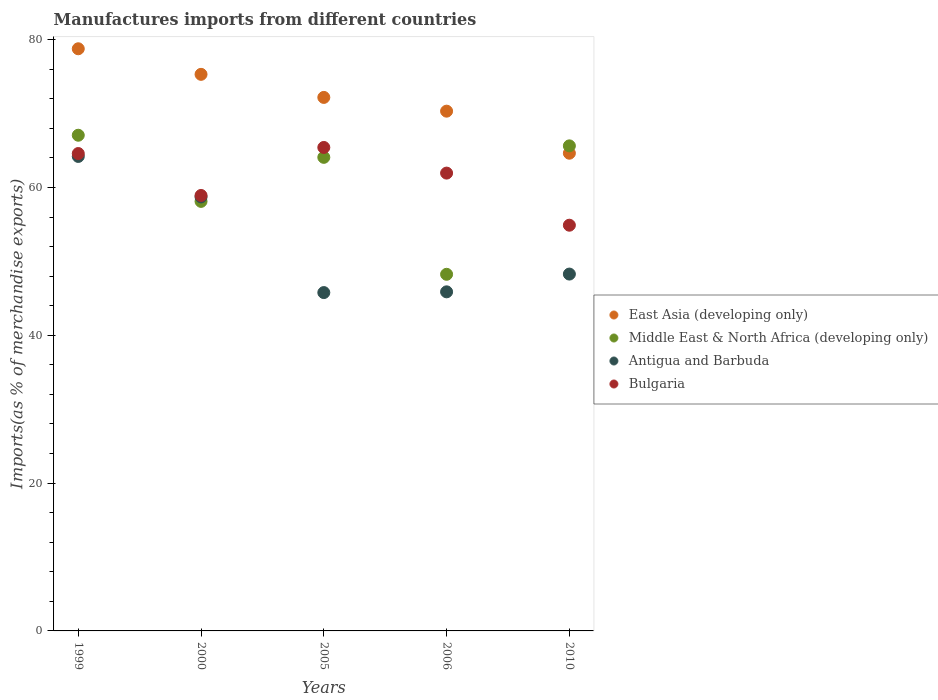How many different coloured dotlines are there?
Make the answer very short. 4. Is the number of dotlines equal to the number of legend labels?
Give a very brief answer. Yes. What is the percentage of imports to different countries in East Asia (developing only) in 2010?
Your answer should be compact. 64.64. Across all years, what is the maximum percentage of imports to different countries in East Asia (developing only)?
Keep it short and to the point. 78.77. Across all years, what is the minimum percentage of imports to different countries in Middle East & North Africa (developing only)?
Your answer should be very brief. 48.25. What is the total percentage of imports to different countries in East Asia (developing only) in the graph?
Your answer should be very brief. 361.24. What is the difference between the percentage of imports to different countries in Middle East & North Africa (developing only) in 1999 and that in 2006?
Provide a succinct answer. 18.82. What is the difference between the percentage of imports to different countries in Middle East & North Africa (developing only) in 2006 and the percentage of imports to different countries in East Asia (developing only) in 1999?
Keep it short and to the point. -30.52. What is the average percentage of imports to different countries in Bulgaria per year?
Give a very brief answer. 61.16. In the year 2000, what is the difference between the percentage of imports to different countries in Bulgaria and percentage of imports to different countries in East Asia (developing only)?
Offer a very short reply. -16.39. What is the ratio of the percentage of imports to different countries in Middle East & North Africa (developing only) in 1999 to that in 2010?
Keep it short and to the point. 1.02. What is the difference between the highest and the second highest percentage of imports to different countries in Middle East & North Africa (developing only)?
Your response must be concise. 1.44. What is the difference between the highest and the lowest percentage of imports to different countries in Antigua and Barbuda?
Give a very brief answer. 18.42. In how many years, is the percentage of imports to different countries in East Asia (developing only) greater than the average percentage of imports to different countries in East Asia (developing only) taken over all years?
Give a very brief answer. 2. Is it the case that in every year, the sum of the percentage of imports to different countries in Antigua and Barbuda and percentage of imports to different countries in Middle East & North Africa (developing only)  is greater than the sum of percentage of imports to different countries in Bulgaria and percentage of imports to different countries in East Asia (developing only)?
Make the answer very short. No. How many dotlines are there?
Give a very brief answer. 4. How many years are there in the graph?
Your answer should be very brief. 5. What is the difference between two consecutive major ticks on the Y-axis?
Provide a succinct answer. 20. Are the values on the major ticks of Y-axis written in scientific E-notation?
Make the answer very short. No. Does the graph contain any zero values?
Provide a succinct answer. No. Does the graph contain grids?
Offer a very short reply. No. How many legend labels are there?
Offer a terse response. 4. What is the title of the graph?
Make the answer very short. Manufactures imports from different countries. What is the label or title of the X-axis?
Your answer should be very brief. Years. What is the label or title of the Y-axis?
Your answer should be compact. Imports(as % of merchandise exports). What is the Imports(as % of merchandise exports) of East Asia (developing only) in 1999?
Keep it short and to the point. 78.77. What is the Imports(as % of merchandise exports) of Middle East & North Africa (developing only) in 1999?
Your answer should be very brief. 67.07. What is the Imports(as % of merchandise exports) in Antigua and Barbuda in 1999?
Offer a terse response. 64.2. What is the Imports(as % of merchandise exports) of Bulgaria in 1999?
Your response must be concise. 64.6. What is the Imports(as % of merchandise exports) of East Asia (developing only) in 2000?
Keep it short and to the point. 75.31. What is the Imports(as % of merchandise exports) of Middle East & North Africa (developing only) in 2000?
Your answer should be very brief. 58.12. What is the Imports(as % of merchandise exports) of Antigua and Barbuda in 2000?
Your response must be concise. 58.72. What is the Imports(as % of merchandise exports) in Bulgaria in 2000?
Offer a terse response. 58.92. What is the Imports(as % of merchandise exports) of East Asia (developing only) in 2005?
Your response must be concise. 72.19. What is the Imports(as % of merchandise exports) in Middle East & North Africa (developing only) in 2005?
Make the answer very short. 64.08. What is the Imports(as % of merchandise exports) of Antigua and Barbuda in 2005?
Your answer should be compact. 45.78. What is the Imports(as % of merchandise exports) in Bulgaria in 2005?
Offer a very short reply. 65.42. What is the Imports(as % of merchandise exports) in East Asia (developing only) in 2006?
Offer a terse response. 70.33. What is the Imports(as % of merchandise exports) in Middle East & North Africa (developing only) in 2006?
Your response must be concise. 48.25. What is the Imports(as % of merchandise exports) in Antigua and Barbuda in 2006?
Provide a short and direct response. 45.88. What is the Imports(as % of merchandise exports) in Bulgaria in 2006?
Offer a terse response. 61.95. What is the Imports(as % of merchandise exports) in East Asia (developing only) in 2010?
Give a very brief answer. 64.64. What is the Imports(as % of merchandise exports) in Middle East & North Africa (developing only) in 2010?
Keep it short and to the point. 65.63. What is the Imports(as % of merchandise exports) in Antigua and Barbuda in 2010?
Your response must be concise. 48.29. What is the Imports(as % of merchandise exports) in Bulgaria in 2010?
Your answer should be very brief. 54.9. Across all years, what is the maximum Imports(as % of merchandise exports) of East Asia (developing only)?
Offer a very short reply. 78.77. Across all years, what is the maximum Imports(as % of merchandise exports) in Middle East & North Africa (developing only)?
Provide a short and direct response. 67.07. Across all years, what is the maximum Imports(as % of merchandise exports) of Antigua and Barbuda?
Offer a terse response. 64.2. Across all years, what is the maximum Imports(as % of merchandise exports) in Bulgaria?
Your response must be concise. 65.42. Across all years, what is the minimum Imports(as % of merchandise exports) in East Asia (developing only)?
Your answer should be very brief. 64.64. Across all years, what is the minimum Imports(as % of merchandise exports) in Middle East & North Africa (developing only)?
Give a very brief answer. 48.25. Across all years, what is the minimum Imports(as % of merchandise exports) of Antigua and Barbuda?
Keep it short and to the point. 45.78. Across all years, what is the minimum Imports(as % of merchandise exports) in Bulgaria?
Your answer should be very brief. 54.9. What is the total Imports(as % of merchandise exports) of East Asia (developing only) in the graph?
Your response must be concise. 361.24. What is the total Imports(as % of merchandise exports) in Middle East & North Africa (developing only) in the graph?
Offer a very short reply. 303.16. What is the total Imports(as % of merchandise exports) in Antigua and Barbuda in the graph?
Your answer should be compact. 262.88. What is the total Imports(as % of merchandise exports) in Bulgaria in the graph?
Your response must be concise. 305.78. What is the difference between the Imports(as % of merchandise exports) in East Asia (developing only) in 1999 and that in 2000?
Offer a very short reply. 3.46. What is the difference between the Imports(as % of merchandise exports) of Middle East & North Africa (developing only) in 1999 and that in 2000?
Your answer should be very brief. 8.95. What is the difference between the Imports(as % of merchandise exports) in Antigua and Barbuda in 1999 and that in 2000?
Your answer should be very brief. 5.48. What is the difference between the Imports(as % of merchandise exports) in Bulgaria in 1999 and that in 2000?
Provide a short and direct response. 5.67. What is the difference between the Imports(as % of merchandise exports) of East Asia (developing only) in 1999 and that in 2005?
Make the answer very short. 6.58. What is the difference between the Imports(as % of merchandise exports) of Middle East & North Africa (developing only) in 1999 and that in 2005?
Ensure brevity in your answer.  2.99. What is the difference between the Imports(as % of merchandise exports) of Antigua and Barbuda in 1999 and that in 2005?
Your answer should be very brief. 18.42. What is the difference between the Imports(as % of merchandise exports) of Bulgaria in 1999 and that in 2005?
Keep it short and to the point. -0.82. What is the difference between the Imports(as % of merchandise exports) in East Asia (developing only) in 1999 and that in 2006?
Provide a short and direct response. 8.44. What is the difference between the Imports(as % of merchandise exports) in Middle East & North Africa (developing only) in 1999 and that in 2006?
Ensure brevity in your answer.  18.82. What is the difference between the Imports(as % of merchandise exports) of Antigua and Barbuda in 1999 and that in 2006?
Ensure brevity in your answer.  18.32. What is the difference between the Imports(as % of merchandise exports) in Bulgaria in 1999 and that in 2006?
Offer a very short reply. 2.65. What is the difference between the Imports(as % of merchandise exports) of East Asia (developing only) in 1999 and that in 2010?
Your response must be concise. 14.13. What is the difference between the Imports(as % of merchandise exports) of Middle East & North Africa (developing only) in 1999 and that in 2010?
Provide a short and direct response. 1.44. What is the difference between the Imports(as % of merchandise exports) in Antigua and Barbuda in 1999 and that in 2010?
Offer a very short reply. 15.92. What is the difference between the Imports(as % of merchandise exports) in Bulgaria in 1999 and that in 2010?
Provide a short and direct response. 9.7. What is the difference between the Imports(as % of merchandise exports) in East Asia (developing only) in 2000 and that in 2005?
Your answer should be very brief. 3.12. What is the difference between the Imports(as % of merchandise exports) of Middle East & North Africa (developing only) in 2000 and that in 2005?
Ensure brevity in your answer.  -5.96. What is the difference between the Imports(as % of merchandise exports) of Antigua and Barbuda in 2000 and that in 2005?
Your response must be concise. 12.94. What is the difference between the Imports(as % of merchandise exports) in Bulgaria in 2000 and that in 2005?
Make the answer very short. -6.49. What is the difference between the Imports(as % of merchandise exports) in East Asia (developing only) in 2000 and that in 2006?
Give a very brief answer. 4.98. What is the difference between the Imports(as % of merchandise exports) in Middle East & North Africa (developing only) in 2000 and that in 2006?
Offer a terse response. 9.87. What is the difference between the Imports(as % of merchandise exports) of Antigua and Barbuda in 2000 and that in 2006?
Your response must be concise. 12.84. What is the difference between the Imports(as % of merchandise exports) of Bulgaria in 2000 and that in 2006?
Your answer should be compact. -3.03. What is the difference between the Imports(as % of merchandise exports) of East Asia (developing only) in 2000 and that in 2010?
Offer a terse response. 10.67. What is the difference between the Imports(as % of merchandise exports) of Middle East & North Africa (developing only) in 2000 and that in 2010?
Your response must be concise. -7.51. What is the difference between the Imports(as % of merchandise exports) of Antigua and Barbuda in 2000 and that in 2010?
Offer a terse response. 10.44. What is the difference between the Imports(as % of merchandise exports) in Bulgaria in 2000 and that in 2010?
Ensure brevity in your answer.  4.02. What is the difference between the Imports(as % of merchandise exports) of East Asia (developing only) in 2005 and that in 2006?
Offer a very short reply. 1.86. What is the difference between the Imports(as % of merchandise exports) in Middle East & North Africa (developing only) in 2005 and that in 2006?
Offer a terse response. 15.83. What is the difference between the Imports(as % of merchandise exports) of Antigua and Barbuda in 2005 and that in 2006?
Offer a very short reply. -0.1. What is the difference between the Imports(as % of merchandise exports) in Bulgaria in 2005 and that in 2006?
Give a very brief answer. 3.47. What is the difference between the Imports(as % of merchandise exports) of East Asia (developing only) in 2005 and that in 2010?
Offer a very short reply. 7.55. What is the difference between the Imports(as % of merchandise exports) of Middle East & North Africa (developing only) in 2005 and that in 2010?
Ensure brevity in your answer.  -1.55. What is the difference between the Imports(as % of merchandise exports) in Antigua and Barbuda in 2005 and that in 2010?
Your answer should be very brief. -2.5. What is the difference between the Imports(as % of merchandise exports) in Bulgaria in 2005 and that in 2010?
Your answer should be very brief. 10.52. What is the difference between the Imports(as % of merchandise exports) in East Asia (developing only) in 2006 and that in 2010?
Offer a very short reply. 5.69. What is the difference between the Imports(as % of merchandise exports) in Middle East & North Africa (developing only) in 2006 and that in 2010?
Ensure brevity in your answer.  -17.38. What is the difference between the Imports(as % of merchandise exports) of Antigua and Barbuda in 2006 and that in 2010?
Provide a short and direct response. -2.4. What is the difference between the Imports(as % of merchandise exports) of Bulgaria in 2006 and that in 2010?
Give a very brief answer. 7.05. What is the difference between the Imports(as % of merchandise exports) in East Asia (developing only) in 1999 and the Imports(as % of merchandise exports) in Middle East & North Africa (developing only) in 2000?
Your answer should be compact. 20.65. What is the difference between the Imports(as % of merchandise exports) in East Asia (developing only) in 1999 and the Imports(as % of merchandise exports) in Antigua and Barbuda in 2000?
Make the answer very short. 20.05. What is the difference between the Imports(as % of merchandise exports) of East Asia (developing only) in 1999 and the Imports(as % of merchandise exports) of Bulgaria in 2000?
Offer a very short reply. 19.85. What is the difference between the Imports(as % of merchandise exports) in Middle East & North Africa (developing only) in 1999 and the Imports(as % of merchandise exports) in Antigua and Barbuda in 2000?
Your answer should be compact. 8.35. What is the difference between the Imports(as % of merchandise exports) of Middle East & North Africa (developing only) in 1999 and the Imports(as % of merchandise exports) of Bulgaria in 2000?
Offer a terse response. 8.15. What is the difference between the Imports(as % of merchandise exports) in Antigua and Barbuda in 1999 and the Imports(as % of merchandise exports) in Bulgaria in 2000?
Your answer should be very brief. 5.28. What is the difference between the Imports(as % of merchandise exports) of East Asia (developing only) in 1999 and the Imports(as % of merchandise exports) of Middle East & North Africa (developing only) in 2005?
Your response must be concise. 14.69. What is the difference between the Imports(as % of merchandise exports) in East Asia (developing only) in 1999 and the Imports(as % of merchandise exports) in Antigua and Barbuda in 2005?
Offer a very short reply. 32.99. What is the difference between the Imports(as % of merchandise exports) in East Asia (developing only) in 1999 and the Imports(as % of merchandise exports) in Bulgaria in 2005?
Your response must be concise. 13.35. What is the difference between the Imports(as % of merchandise exports) of Middle East & North Africa (developing only) in 1999 and the Imports(as % of merchandise exports) of Antigua and Barbuda in 2005?
Keep it short and to the point. 21.29. What is the difference between the Imports(as % of merchandise exports) in Middle East & North Africa (developing only) in 1999 and the Imports(as % of merchandise exports) in Bulgaria in 2005?
Offer a terse response. 1.65. What is the difference between the Imports(as % of merchandise exports) in Antigua and Barbuda in 1999 and the Imports(as % of merchandise exports) in Bulgaria in 2005?
Keep it short and to the point. -1.21. What is the difference between the Imports(as % of merchandise exports) in East Asia (developing only) in 1999 and the Imports(as % of merchandise exports) in Middle East & North Africa (developing only) in 2006?
Provide a succinct answer. 30.52. What is the difference between the Imports(as % of merchandise exports) in East Asia (developing only) in 1999 and the Imports(as % of merchandise exports) in Antigua and Barbuda in 2006?
Give a very brief answer. 32.89. What is the difference between the Imports(as % of merchandise exports) in East Asia (developing only) in 1999 and the Imports(as % of merchandise exports) in Bulgaria in 2006?
Your answer should be very brief. 16.82. What is the difference between the Imports(as % of merchandise exports) in Middle East & North Africa (developing only) in 1999 and the Imports(as % of merchandise exports) in Antigua and Barbuda in 2006?
Your answer should be very brief. 21.19. What is the difference between the Imports(as % of merchandise exports) in Middle East & North Africa (developing only) in 1999 and the Imports(as % of merchandise exports) in Bulgaria in 2006?
Your response must be concise. 5.12. What is the difference between the Imports(as % of merchandise exports) in Antigua and Barbuda in 1999 and the Imports(as % of merchandise exports) in Bulgaria in 2006?
Offer a very short reply. 2.26. What is the difference between the Imports(as % of merchandise exports) of East Asia (developing only) in 1999 and the Imports(as % of merchandise exports) of Middle East & North Africa (developing only) in 2010?
Ensure brevity in your answer.  13.14. What is the difference between the Imports(as % of merchandise exports) of East Asia (developing only) in 1999 and the Imports(as % of merchandise exports) of Antigua and Barbuda in 2010?
Give a very brief answer. 30.49. What is the difference between the Imports(as % of merchandise exports) in East Asia (developing only) in 1999 and the Imports(as % of merchandise exports) in Bulgaria in 2010?
Your response must be concise. 23.87. What is the difference between the Imports(as % of merchandise exports) of Middle East & North Africa (developing only) in 1999 and the Imports(as % of merchandise exports) of Antigua and Barbuda in 2010?
Offer a terse response. 18.79. What is the difference between the Imports(as % of merchandise exports) in Middle East & North Africa (developing only) in 1999 and the Imports(as % of merchandise exports) in Bulgaria in 2010?
Keep it short and to the point. 12.17. What is the difference between the Imports(as % of merchandise exports) in Antigua and Barbuda in 1999 and the Imports(as % of merchandise exports) in Bulgaria in 2010?
Your answer should be compact. 9.31. What is the difference between the Imports(as % of merchandise exports) in East Asia (developing only) in 2000 and the Imports(as % of merchandise exports) in Middle East & North Africa (developing only) in 2005?
Keep it short and to the point. 11.23. What is the difference between the Imports(as % of merchandise exports) in East Asia (developing only) in 2000 and the Imports(as % of merchandise exports) in Antigua and Barbuda in 2005?
Make the answer very short. 29.53. What is the difference between the Imports(as % of merchandise exports) of East Asia (developing only) in 2000 and the Imports(as % of merchandise exports) of Bulgaria in 2005?
Provide a short and direct response. 9.89. What is the difference between the Imports(as % of merchandise exports) in Middle East & North Africa (developing only) in 2000 and the Imports(as % of merchandise exports) in Antigua and Barbuda in 2005?
Keep it short and to the point. 12.34. What is the difference between the Imports(as % of merchandise exports) of Middle East & North Africa (developing only) in 2000 and the Imports(as % of merchandise exports) of Bulgaria in 2005?
Offer a terse response. -7.3. What is the difference between the Imports(as % of merchandise exports) of Antigua and Barbuda in 2000 and the Imports(as % of merchandise exports) of Bulgaria in 2005?
Offer a terse response. -6.69. What is the difference between the Imports(as % of merchandise exports) of East Asia (developing only) in 2000 and the Imports(as % of merchandise exports) of Middle East & North Africa (developing only) in 2006?
Your answer should be very brief. 27.06. What is the difference between the Imports(as % of merchandise exports) in East Asia (developing only) in 2000 and the Imports(as % of merchandise exports) in Antigua and Barbuda in 2006?
Ensure brevity in your answer.  29.43. What is the difference between the Imports(as % of merchandise exports) in East Asia (developing only) in 2000 and the Imports(as % of merchandise exports) in Bulgaria in 2006?
Your answer should be very brief. 13.36. What is the difference between the Imports(as % of merchandise exports) of Middle East & North Africa (developing only) in 2000 and the Imports(as % of merchandise exports) of Antigua and Barbuda in 2006?
Your answer should be very brief. 12.24. What is the difference between the Imports(as % of merchandise exports) in Middle East & North Africa (developing only) in 2000 and the Imports(as % of merchandise exports) in Bulgaria in 2006?
Give a very brief answer. -3.83. What is the difference between the Imports(as % of merchandise exports) in Antigua and Barbuda in 2000 and the Imports(as % of merchandise exports) in Bulgaria in 2006?
Make the answer very short. -3.22. What is the difference between the Imports(as % of merchandise exports) in East Asia (developing only) in 2000 and the Imports(as % of merchandise exports) in Middle East & North Africa (developing only) in 2010?
Keep it short and to the point. 9.68. What is the difference between the Imports(as % of merchandise exports) of East Asia (developing only) in 2000 and the Imports(as % of merchandise exports) of Antigua and Barbuda in 2010?
Your answer should be compact. 27.03. What is the difference between the Imports(as % of merchandise exports) in East Asia (developing only) in 2000 and the Imports(as % of merchandise exports) in Bulgaria in 2010?
Your response must be concise. 20.41. What is the difference between the Imports(as % of merchandise exports) in Middle East & North Africa (developing only) in 2000 and the Imports(as % of merchandise exports) in Antigua and Barbuda in 2010?
Provide a short and direct response. 9.83. What is the difference between the Imports(as % of merchandise exports) in Middle East & North Africa (developing only) in 2000 and the Imports(as % of merchandise exports) in Bulgaria in 2010?
Your answer should be compact. 3.22. What is the difference between the Imports(as % of merchandise exports) in Antigua and Barbuda in 2000 and the Imports(as % of merchandise exports) in Bulgaria in 2010?
Provide a short and direct response. 3.83. What is the difference between the Imports(as % of merchandise exports) in East Asia (developing only) in 2005 and the Imports(as % of merchandise exports) in Middle East & North Africa (developing only) in 2006?
Give a very brief answer. 23.93. What is the difference between the Imports(as % of merchandise exports) of East Asia (developing only) in 2005 and the Imports(as % of merchandise exports) of Antigua and Barbuda in 2006?
Provide a short and direct response. 26.31. What is the difference between the Imports(as % of merchandise exports) in East Asia (developing only) in 2005 and the Imports(as % of merchandise exports) in Bulgaria in 2006?
Provide a short and direct response. 10.24. What is the difference between the Imports(as % of merchandise exports) in Middle East & North Africa (developing only) in 2005 and the Imports(as % of merchandise exports) in Antigua and Barbuda in 2006?
Your answer should be compact. 18.2. What is the difference between the Imports(as % of merchandise exports) in Middle East & North Africa (developing only) in 2005 and the Imports(as % of merchandise exports) in Bulgaria in 2006?
Make the answer very short. 2.13. What is the difference between the Imports(as % of merchandise exports) of Antigua and Barbuda in 2005 and the Imports(as % of merchandise exports) of Bulgaria in 2006?
Offer a very short reply. -16.17. What is the difference between the Imports(as % of merchandise exports) in East Asia (developing only) in 2005 and the Imports(as % of merchandise exports) in Middle East & North Africa (developing only) in 2010?
Keep it short and to the point. 6.56. What is the difference between the Imports(as % of merchandise exports) in East Asia (developing only) in 2005 and the Imports(as % of merchandise exports) in Antigua and Barbuda in 2010?
Give a very brief answer. 23.9. What is the difference between the Imports(as % of merchandise exports) of East Asia (developing only) in 2005 and the Imports(as % of merchandise exports) of Bulgaria in 2010?
Offer a terse response. 17.29. What is the difference between the Imports(as % of merchandise exports) in Middle East & North Africa (developing only) in 2005 and the Imports(as % of merchandise exports) in Antigua and Barbuda in 2010?
Your answer should be very brief. 15.79. What is the difference between the Imports(as % of merchandise exports) of Middle East & North Africa (developing only) in 2005 and the Imports(as % of merchandise exports) of Bulgaria in 2010?
Make the answer very short. 9.18. What is the difference between the Imports(as % of merchandise exports) of Antigua and Barbuda in 2005 and the Imports(as % of merchandise exports) of Bulgaria in 2010?
Give a very brief answer. -9.12. What is the difference between the Imports(as % of merchandise exports) of East Asia (developing only) in 2006 and the Imports(as % of merchandise exports) of Middle East & North Africa (developing only) in 2010?
Offer a very short reply. 4.7. What is the difference between the Imports(as % of merchandise exports) in East Asia (developing only) in 2006 and the Imports(as % of merchandise exports) in Antigua and Barbuda in 2010?
Your response must be concise. 22.04. What is the difference between the Imports(as % of merchandise exports) of East Asia (developing only) in 2006 and the Imports(as % of merchandise exports) of Bulgaria in 2010?
Give a very brief answer. 15.43. What is the difference between the Imports(as % of merchandise exports) in Middle East & North Africa (developing only) in 2006 and the Imports(as % of merchandise exports) in Antigua and Barbuda in 2010?
Your answer should be compact. -0.03. What is the difference between the Imports(as % of merchandise exports) in Middle East & North Africa (developing only) in 2006 and the Imports(as % of merchandise exports) in Bulgaria in 2010?
Offer a very short reply. -6.64. What is the difference between the Imports(as % of merchandise exports) in Antigua and Barbuda in 2006 and the Imports(as % of merchandise exports) in Bulgaria in 2010?
Give a very brief answer. -9.02. What is the average Imports(as % of merchandise exports) in East Asia (developing only) per year?
Keep it short and to the point. 72.25. What is the average Imports(as % of merchandise exports) of Middle East & North Africa (developing only) per year?
Offer a very short reply. 60.63. What is the average Imports(as % of merchandise exports) in Antigua and Barbuda per year?
Give a very brief answer. 52.58. What is the average Imports(as % of merchandise exports) of Bulgaria per year?
Your answer should be very brief. 61.16. In the year 1999, what is the difference between the Imports(as % of merchandise exports) of East Asia (developing only) and Imports(as % of merchandise exports) of Middle East & North Africa (developing only)?
Provide a succinct answer. 11.7. In the year 1999, what is the difference between the Imports(as % of merchandise exports) of East Asia (developing only) and Imports(as % of merchandise exports) of Antigua and Barbuda?
Provide a succinct answer. 14.57. In the year 1999, what is the difference between the Imports(as % of merchandise exports) of East Asia (developing only) and Imports(as % of merchandise exports) of Bulgaria?
Offer a terse response. 14.18. In the year 1999, what is the difference between the Imports(as % of merchandise exports) in Middle East & North Africa (developing only) and Imports(as % of merchandise exports) in Antigua and Barbuda?
Offer a very short reply. 2.87. In the year 1999, what is the difference between the Imports(as % of merchandise exports) of Middle East & North Africa (developing only) and Imports(as % of merchandise exports) of Bulgaria?
Ensure brevity in your answer.  2.48. In the year 1999, what is the difference between the Imports(as % of merchandise exports) in Antigua and Barbuda and Imports(as % of merchandise exports) in Bulgaria?
Your response must be concise. -0.39. In the year 2000, what is the difference between the Imports(as % of merchandise exports) of East Asia (developing only) and Imports(as % of merchandise exports) of Middle East & North Africa (developing only)?
Offer a very short reply. 17.19. In the year 2000, what is the difference between the Imports(as % of merchandise exports) of East Asia (developing only) and Imports(as % of merchandise exports) of Antigua and Barbuda?
Keep it short and to the point. 16.59. In the year 2000, what is the difference between the Imports(as % of merchandise exports) in East Asia (developing only) and Imports(as % of merchandise exports) in Bulgaria?
Your answer should be compact. 16.39. In the year 2000, what is the difference between the Imports(as % of merchandise exports) of Middle East & North Africa (developing only) and Imports(as % of merchandise exports) of Antigua and Barbuda?
Ensure brevity in your answer.  -0.6. In the year 2000, what is the difference between the Imports(as % of merchandise exports) in Middle East & North Africa (developing only) and Imports(as % of merchandise exports) in Bulgaria?
Provide a succinct answer. -0.8. In the year 2000, what is the difference between the Imports(as % of merchandise exports) of Antigua and Barbuda and Imports(as % of merchandise exports) of Bulgaria?
Your answer should be very brief. -0.2. In the year 2005, what is the difference between the Imports(as % of merchandise exports) in East Asia (developing only) and Imports(as % of merchandise exports) in Middle East & North Africa (developing only)?
Offer a terse response. 8.11. In the year 2005, what is the difference between the Imports(as % of merchandise exports) of East Asia (developing only) and Imports(as % of merchandise exports) of Antigua and Barbuda?
Offer a terse response. 26.41. In the year 2005, what is the difference between the Imports(as % of merchandise exports) in East Asia (developing only) and Imports(as % of merchandise exports) in Bulgaria?
Keep it short and to the point. 6.77. In the year 2005, what is the difference between the Imports(as % of merchandise exports) in Middle East & North Africa (developing only) and Imports(as % of merchandise exports) in Antigua and Barbuda?
Ensure brevity in your answer.  18.3. In the year 2005, what is the difference between the Imports(as % of merchandise exports) of Middle East & North Africa (developing only) and Imports(as % of merchandise exports) of Bulgaria?
Give a very brief answer. -1.34. In the year 2005, what is the difference between the Imports(as % of merchandise exports) of Antigua and Barbuda and Imports(as % of merchandise exports) of Bulgaria?
Provide a succinct answer. -19.64. In the year 2006, what is the difference between the Imports(as % of merchandise exports) in East Asia (developing only) and Imports(as % of merchandise exports) in Middle East & North Africa (developing only)?
Provide a succinct answer. 22.07. In the year 2006, what is the difference between the Imports(as % of merchandise exports) of East Asia (developing only) and Imports(as % of merchandise exports) of Antigua and Barbuda?
Your answer should be very brief. 24.45. In the year 2006, what is the difference between the Imports(as % of merchandise exports) of East Asia (developing only) and Imports(as % of merchandise exports) of Bulgaria?
Make the answer very short. 8.38. In the year 2006, what is the difference between the Imports(as % of merchandise exports) in Middle East & North Africa (developing only) and Imports(as % of merchandise exports) in Antigua and Barbuda?
Ensure brevity in your answer.  2.37. In the year 2006, what is the difference between the Imports(as % of merchandise exports) of Middle East & North Africa (developing only) and Imports(as % of merchandise exports) of Bulgaria?
Your answer should be very brief. -13.69. In the year 2006, what is the difference between the Imports(as % of merchandise exports) in Antigua and Barbuda and Imports(as % of merchandise exports) in Bulgaria?
Keep it short and to the point. -16.07. In the year 2010, what is the difference between the Imports(as % of merchandise exports) in East Asia (developing only) and Imports(as % of merchandise exports) in Middle East & North Africa (developing only)?
Make the answer very short. -0.99. In the year 2010, what is the difference between the Imports(as % of merchandise exports) of East Asia (developing only) and Imports(as % of merchandise exports) of Antigua and Barbuda?
Provide a short and direct response. 16.35. In the year 2010, what is the difference between the Imports(as % of merchandise exports) of East Asia (developing only) and Imports(as % of merchandise exports) of Bulgaria?
Keep it short and to the point. 9.74. In the year 2010, what is the difference between the Imports(as % of merchandise exports) of Middle East & North Africa (developing only) and Imports(as % of merchandise exports) of Antigua and Barbuda?
Your response must be concise. 17.35. In the year 2010, what is the difference between the Imports(as % of merchandise exports) in Middle East & North Africa (developing only) and Imports(as % of merchandise exports) in Bulgaria?
Make the answer very short. 10.74. In the year 2010, what is the difference between the Imports(as % of merchandise exports) of Antigua and Barbuda and Imports(as % of merchandise exports) of Bulgaria?
Keep it short and to the point. -6.61. What is the ratio of the Imports(as % of merchandise exports) of East Asia (developing only) in 1999 to that in 2000?
Offer a very short reply. 1.05. What is the ratio of the Imports(as % of merchandise exports) in Middle East & North Africa (developing only) in 1999 to that in 2000?
Your answer should be compact. 1.15. What is the ratio of the Imports(as % of merchandise exports) in Antigua and Barbuda in 1999 to that in 2000?
Your answer should be very brief. 1.09. What is the ratio of the Imports(as % of merchandise exports) of Bulgaria in 1999 to that in 2000?
Make the answer very short. 1.1. What is the ratio of the Imports(as % of merchandise exports) in East Asia (developing only) in 1999 to that in 2005?
Make the answer very short. 1.09. What is the ratio of the Imports(as % of merchandise exports) of Middle East & North Africa (developing only) in 1999 to that in 2005?
Keep it short and to the point. 1.05. What is the ratio of the Imports(as % of merchandise exports) in Antigua and Barbuda in 1999 to that in 2005?
Ensure brevity in your answer.  1.4. What is the ratio of the Imports(as % of merchandise exports) of Bulgaria in 1999 to that in 2005?
Your answer should be compact. 0.99. What is the ratio of the Imports(as % of merchandise exports) of East Asia (developing only) in 1999 to that in 2006?
Offer a very short reply. 1.12. What is the ratio of the Imports(as % of merchandise exports) of Middle East & North Africa (developing only) in 1999 to that in 2006?
Make the answer very short. 1.39. What is the ratio of the Imports(as % of merchandise exports) in Antigua and Barbuda in 1999 to that in 2006?
Offer a terse response. 1.4. What is the ratio of the Imports(as % of merchandise exports) in Bulgaria in 1999 to that in 2006?
Your answer should be compact. 1.04. What is the ratio of the Imports(as % of merchandise exports) in East Asia (developing only) in 1999 to that in 2010?
Provide a short and direct response. 1.22. What is the ratio of the Imports(as % of merchandise exports) of Middle East & North Africa (developing only) in 1999 to that in 2010?
Your answer should be compact. 1.02. What is the ratio of the Imports(as % of merchandise exports) in Antigua and Barbuda in 1999 to that in 2010?
Offer a terse response. 1.33. What is the ratio of the Imports(as % of merchandise exports) in Bulgaria in 1999 to that in 2010?
Provide a short and direct response. 1.18. What is the ratio of the Imports(as % of merchandise exports) of East Asia (developing only) in 2000 to that in 2005?
Offer a very short reply. 1.04. What is the ratio of the Imports(as % of merchandise exports) of Middle East & North Africa (developing only) in 2000 to that in 2005?
Provide a short and direct response. 0.91. What is the ratio of the Imports(as % of merchandise exports) of Antigua and Barbuda in 2000 to that in 2005?
Your response must be concise. 1.28. What is the ratio of the Imports(as % of merchandise exports) in Bulgaria in 2000 to that in 2005?
Keep it short and to the point. 0.9. What is the ratio of the Imports(as % of merchandise exports) in East Asia (developing only) in 2000 to that in 2006?
Give a very brief answer. 1.07. What is the ratio of the Imports(as % of merchandise exports) in Middle East & North Africa (developing only) in 2000 to that in 2006?
Give a very brief answer. 1.2. What is the ratio of the Imports(as % of merchandise exports) in Antigua and Barbuda in 2000 to that in 2006?
Ensure brevity in your answer.  1.28. What is the ratio of the Imports(as % of merchandise exports) in Bulgaria in 2000 to that in 2006?
Your response must be concise. 0.95. What is the ratio of the Imports(as % of merchandise exports) of East Asia (developing only) in 2000 to that in 2010?
Keep it short and to the point. 1.17. What is the ratio of the Imports(as % of merchandise exports) of Middle East & North Africa (developing only) in 2000 to that in 2010?
Offer a very short reply. 0.89. What is the ratio of the Imports(as % of merchandise exports) of Antigua and Barbuda in 2000 to that in 2010?
Your response must be concise. 1.22. What is the ratio of the Imports(as % of merchandise exports) of Bulgaria in 2000 to that in 2010?
Provide a short and direct response. 1.07. What is the ratio of the Imports(as % of merchandise exports) in East Asia (developing only) in 2005 to that in 2006?
Keep it short and to the point. 1.03. What is the ratio of the Imports(as % of merchandise exports) in Middle East & North Africa (developing only) in 2005 to that in 2006?
Give a very brief answer. 1.33. What is the ratio of the Imports(as % of merchandise exports) of Antigua and Barbuda in 2005 to that in 2006?
Give a very brief answer. 1. What is the ratio of the Imports(as % of merchandise exports) in Bulgaria in 2005 to that in 2006?
Make the answer very short. 1.06. What is the ratio of the Imports(as % of merchandise exports) of East Asia (developing only) in 2005 to that in 2010?
Keep it short and to the point. 1.12. What is the ratio of the Imports(as % of merchandise exports) of Middle East & North Africa (developing only) in 2005 to that in 2010?
Your response must be concise. 0.98. What is the ratio of the Imports(as % of merchandise exports) of Antigua and Barbuda in 2005 to that in 2010?
Keep it short and to the point. 0.95. What is the ratio of the Imports(as % of merchandise exports) in Bulgaria in 2005 to that in 2010?
Offer a terse response. 1.19. What is the ratio of the Imports(as % of merchandise exports) of East Asia (developing only) in 2006 to that in 2010?
Ensure brevity in your answer.  1.09. What is the ratio of the Imports(as % of merchandise exports) of Middle East & North Africa (developing only) in 2006 to that in 2010?
Provide a short and direct response. 0.74. What is the ratio of the Imports(as % of merchandise exports) in Antigua and Barbuda in 2006 to that in 2010?
Ensure brevity in your answer.  0.95. What is the ratio of the Imports(as % of merchandise exports) in Bulgaria in 2006 to that in 2010?
Provide a succinct answer. 1.13. What is the difference between the highest and the second highest Imports(as % of merchandise exports) of East Asia (developing only)?
Your response must be concise. 3.46. What is the difference between the highest and the second highest Imports(as % of merchandise exports) of Middle East & North Africa (developing only)?
Keep it short and to the point. 1.44. What is the difference between the highest and the second highest Imports(as % of merchandise exports) in Antigua and Barbuda?
Ensure brevity in your answer.  5.48. What is the difference between the highest and the second highest Imports(as % of merchandise exports) of Bulgaria?
Your response must be concise. 0.82. What is the difference between the highest and the lowest Imports(as % of merchandise exports) of East Asia (developing only)?
Make the answer very short. 14.13. What is the difference between the highest and the lowest Imports(as % of merchandise exports) in Middle East & North Africa (developing only)?
Offer a very short reply. 18.82. What is the difference between the highest and the lowest Imports(as % of merchandise exports) in Antigua and Barbuda?
Provide a succinct answer. 18.42. What is the difference between the highest and the lowest Imports(as % of merchandise exports) in Bulgaria?
Your answer should be very brief. 10.52. 